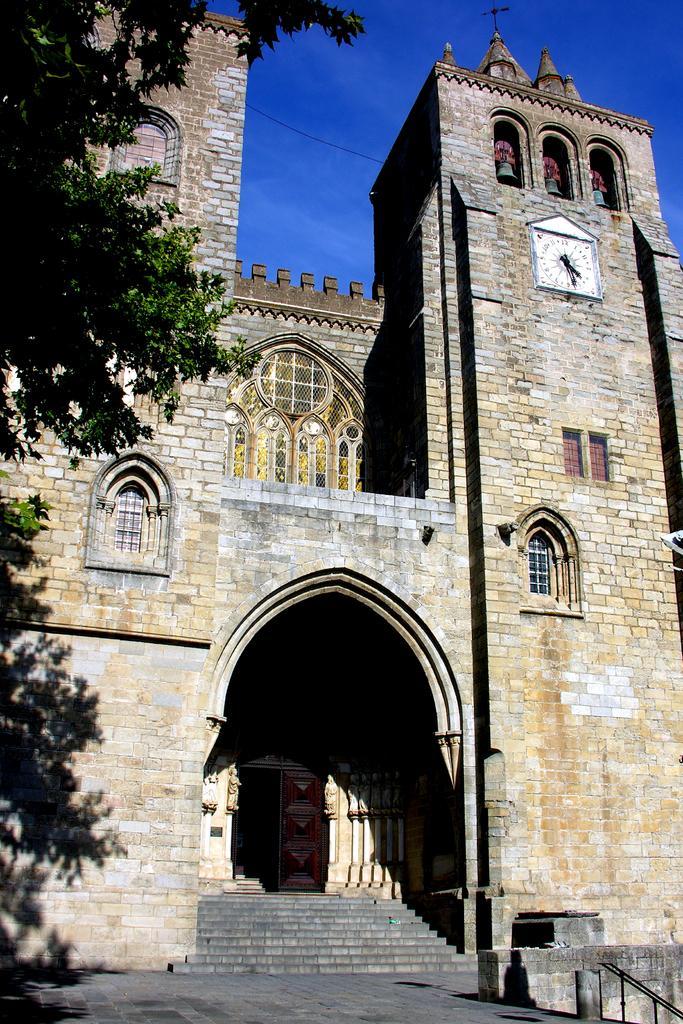How would you summarize this image in a sentence or two? In this image in the front there are leaves. In the background there is a castle and there is a clock on the wall of the castle, there are steps and on the right side there is a railing and the top there is sky. 